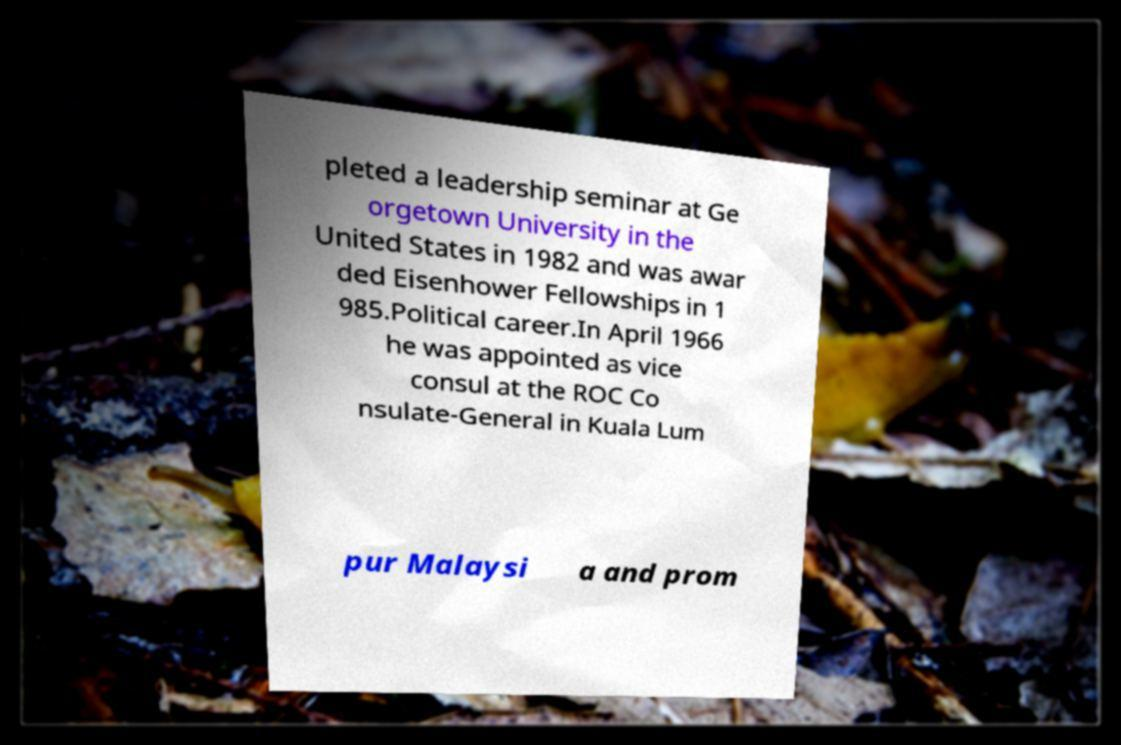What messages or text are displayed in this image? I need them in a readable, typed format. pleted a leadership seminar at Ge orgetown University in the United States in 1982 and was awar ded Eisenhower Fellowships in 1 985.Political career.In April 1966 he was appointed as vice consul at the ROC Co nsulate-General in Kuala Lum pur Malaysi a and prom 